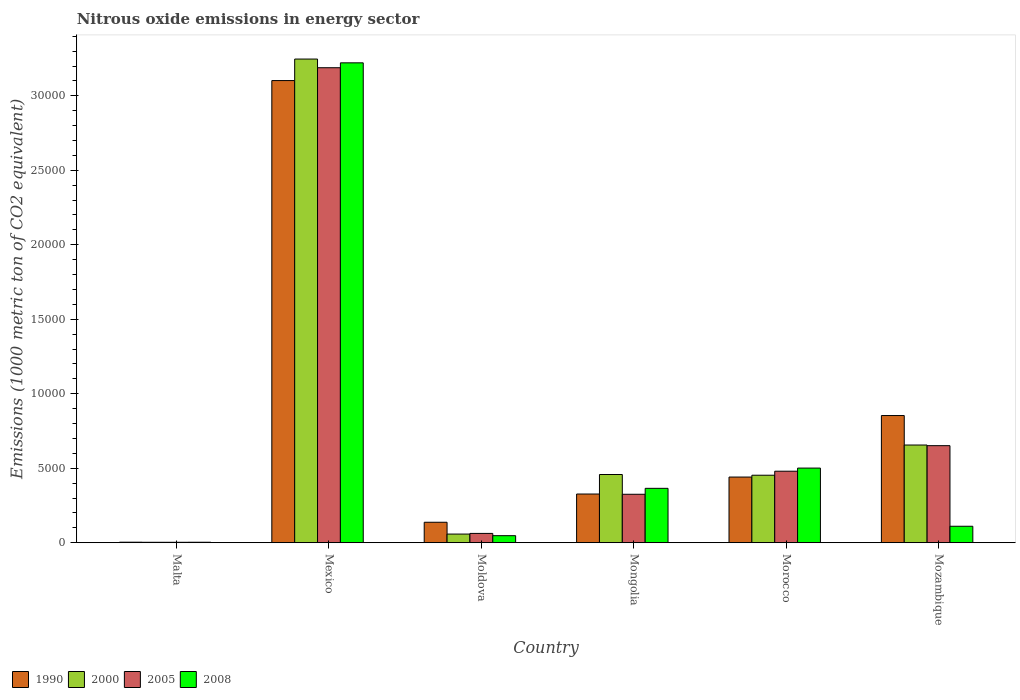How many groups of bars are there?
Ensure brevity in your answer.  6. Are the number of bars per tick equal to the number of legend labels?
Give a very brief answer. Yes. How many bars are there on the 4th tick from the left?
Offer a terse response. 4. What is the label of the 5th group of bars from the left?
Keep it short and to the point. Morocco. In how many cases, is the number of bars for a given country not equal to the number of legend labels?
Your answer should be compact. 0. What is the amount of nitrous oxide emitted in 2005 in Mozambique?
Make the answer very short. 6514.2. Across all countries, what is the maximum amount of nitrous oxide emitted in 2008?
Your response must be concise. 3.22e+04. Across all countries, what is the minimum amount of nitrous oxide emitted in 2005?
Offer a terse response. 28.7. In which country was the amount of nitrous oxide emitted in 2000 minimum?
Offer a terse response. Malta. What is the total amount of nitrous oxide emitted in 2000 in the graph?
Give a very brief answer. 4.87e+04. What is the difference between the amount of nitrous oxide emitted in 2000 in Moldova and that in Mongolia?
Keep it short and to the point. -3998.7. What is the difference between the amount of nitrous oxide emitted in 1990 in Moldova and the amount of nitrous oxide emitted in 2000 in Mongolia?
Your response must be concise. -3205.3. What is the average amount of nitrous oxide emitted in 2005 per country?
Your answer should be compact. 7850.5. What is the difference between the amount of nitrous oxide emitted of/in 2005 and amount of nitrous oxide emitted of/in 2008 in Malta?
Your answer should be very brief. -2.4. What is the ratio of the amount of nitrous oxide emitted in 2005 in Moldova to that in Morocco?
Provide a succinct answer. 0.13. What is the difference between the highest and the second highest amount of nitrous oxide emitted in 1990?
Your answer should be very brief. -4130.1. What is the difference between the highest and the lowest amount of nitrous oxide emitted in 1990?
Give a very brief answer. 3.10e+04. In how many countries, is the amount of nitrous oxide emitted in 1990 greater than the average amount of nitrous oxide emitted in 1990 taken over all countries?
Ensure brevity in your answer.  2. Is the sum of the amount of nitrous oxide emitted in 2008 in Moldova and Mongolia greater than the maximum amount of nitrous oxide emitted in 1990 across all countries?
Your response must be concise. No. What is the difference between two consecutive major ticks on the Y-axis?
Your answer should be very brief. 5000. Are the values on the major ticks of Y-axis written in scientific E-notation?
Your answer should be very brief. No. Does the graph contain any zero values?
Your answer should be very brief. No. Does the graph contain grids?
Your answer should be compact. No. Where does the legend appear in the graph?
Keep it short and to the point. Bottom left. How are the legend labels stacked?
Ensure brevity in your answer.  Horizontal. What is the title of the graph?
Provide a short and direct response. Nitrous oxide emissions in energy sector. Does "1973" appear as one of the legend labels in the graph?
Your answer should be very brief. No. What is the label or title of the Y-axis?
Offer a terse response. Emissions (1000 metric ton of CO2 equivalent). What is the Emissions (1000 metric ton of CO2 equivalent) in 2000 in Malta?
Your answer should be compact. 28.2. What is the Emissions (1000 metric ton of CO2 equivalent) in 2005 in Malta?
Your answer should be very brief. 28.7. What is the Emissions (1000 metric ton of CO2 equivalent) in 2008 in Malta?
Offer a terse response. 31.1. What is the Emissions (1000 metric ton of CO2 equivalent) of 1990 in Mexico?
Offer a very short reply. 3.10e+04. What is the Emissions (1000 metric ton of CO2 equivalent) of 2000 in Mexico?
Make the answer very short. 3.25e+04. What is the Emissions (1000 metric ton of CO2 equivalent) of 2005 in Mexico?
Offer a very short reply. 3.19e+04. What is the Emissions (1000 metric ton of CO2 equivalent) of 2008 in Mexico?
Provide a short and direct response. 3.22e+04. What is the Emissions (1000 metric ton of CO2 equivalent) in 1990 in Moldova?
Provide a short and direct response. 1373.3. What is the Emissions (1000 metric ton of CO2 equivalent) of 2000 in Moldova?
Provide a succinct answer. 579.9. What is the Emissions (1000 metric ton of CO2 equivalent) in 2005 in Moldova?
Your response must be concise. 624.1. What is the Emissions (1000 metric ton of CO2 equivalent) in 2008 in Moldova?
Keep it short and to the point. 472.4. What is the Emissions (1000 metric ton of CO2 equivalent) of 1990 in Mongolia?
Keep it short and to the point. 3267.8. What is the Emissions (1000 metric ton of CO2 equivalent) in 2000 in Mongolia?
Provide a succinct answer. 4578.6. What is the Emissions (1000 metric ton of CO2 equivalent) in 2005 in Mongolia?
Offer a very short reply. 3251.9. What is the Emissions (1000 metric ton of CO2 equivalent) of 2008 in Mongolia?
Keep it short and to the point. 3650.1. What is the Emissions (1000 metric ton of CO2 equivalent) in 1990 in Morocco?
Your response must be concise. 4406.9. What is the Emissions (1000 metric ton of CO2 equivalent) in 2000 in Morocco?
Make the answer very short. 4529.5. What is the Emissions (1000 metric ton of CO2 equivalent) of 2005 in Morocco?
Make the answer very short. 4799.4. What is the Emissions (1000 metric ton of CO2 equivalent) in 2008 in Morocco?
Your response must be concise. 5008.9. What is the Emissions (1000 metric ton of CO2 equivalent) in 1990 in Mozambique?
Ensure brevity in your answer.  8537. What is the Emissions (1000 metric ton of CO2 equivalent) in 2000 in Mozambique?
Ensure brevity in your answer.  6557.2. What is the Emissions (1000 metric ton of CO2 equivalent) of 2005 in Mozambique?
Your answer should be very brief. 6514.2. What is the Emissions (1000 metric ton of CO2 equivalent) in 2008 in Mozambique?
Make the answer very short. 1104.1. Across all countries, what is the maximum Emissions (1000 metric ton of CO2 equivalent) of 1990?
Give a very brief answer. 3.10e+04. Across all countries, what is the maximum Emissions (1000 metric ton of CO2 equivalent) in 2000?
Make the answer very short. 3.25e+04. Across all countries, what is the maximum Emissions (1000 metric ton of CO2 equivalent) in 2005?
Your response must be concise. 3.19e+04. Across all countries, what is the maximum Emissions (1000 metric ton of CO2 equivalent) in 2008?
Offer a very short reply. 3.22e+04. Across all countries, what is the minimum Emissions (1000 metric ton of CO2 equivalent) of 1990?
Your response must be concise. 35. Across all countries, what is the minimum Emissions (1000 metric ton of CO2 equivalent) of 2000?
Your response must be concise. 28.2. Across all countries, what is the minimum Emissions (1000 metric ton of CO2 equivalent) in 2005?
Make the answer very short. 28.7. Across all countries, what is the minimum Emissions (1000 metric ton of CO2 equivalent) of 2008?
Keep it short and to the point. 31.1. What is the total Emissions (1000 metric ton of CO2 equivalent) in 1990 in the graph?
Ensure brevity in your answer.  4.86e+04. What is the total Emissions (1000 metric ton of CO2 equivalent) of 2000 in the graph?
Offer a very short reply. 4.87e+04. What is the total Emissions (1000 metric ton of CO2 equivalent) in 2005 in the graph?
Provide a short and direct response. 4.71e+04. What is the total Emissions (1000 metric ton of CO2 equivalent) of 2008 in the graph?
Offer a very short reply. 4.25e+04. What is the difference between the Emissions (1000 metric ton of CO2 equivalent) in 1990 in Malta and that in Mexico?
Keep it short and to the point. -3.10e+04. What is the difference between the Emissions (1000 metric ton of CO2 equivalent) in 2000 in Malta and that in Mexico?
Make the answer very short. -3.24e+04. What is the difference between the Emissions (1000 metric ton of CO2 equivalent) in 2005 in Malta and that in Mexico?
Provide a short and direct response. -3.19e+04. What is the difference between the Emissions (1000 metric ton of CO2 equivalent) of 2008 in Malta and that in Mexico?
Ensure brevity in your answer.  -3.22e+04. What is the difference between the Emissions (1000 metric ton of CO2 equivalent) of 1990 in Malta and that in Moldova?
Your answer should be compact. -1338.3. What is the difference between the Emissions (1000 metric ton of CO2 equivalent) in 2000 in Malta and that in Moldova?
Your answer should be compact. -551.7. What is the difference between the Emissions (1000 metric ton of CO2 equivalent) in 2005 in Malta and that in Moldova?
Give a very brief answer. -595.4. What is the difference between the Emissions (1000 metric ton of CO2 equivalent) of 2008 in Malta and that in Moldova?
Your response must be concise. -441.3. What is the difference between the Emissions (1000 metric ton of CO2 equivalent) of 1990 in Malta and that in Mongolia?
Your response must be concise. -3232.8. What is the difference between the Emissions (1000 metric ton of CO2 equivalent) of 2000 in Malta and that in Mongolia?
Ensure brevity in your answer.  -4550.4. What is the difference between the Emissions (1000 metric ton of CO2 equivalent) of 2005 in Malta and that in Mongolia?
Provide a short and direct response. -3223.2. What is the difference between the Emissions (1000 metric ton of CO2 equivalent) of 2008 in Malta and that in Mongolia?
Provide a short and direct response. -3619. What is the difference between the Emissions (1000 metric ton of CO2 equivalent) in 1990 in Malta and that in Morocco?
Provide a short and direct response. -4371.9. What is the difference between the Emissions (1000 metric ton of CO2 equivalent) in 2000 in Malta and that in Morocco?
Offer a terse response. -4501.3. What is the difference between the Emissions (1000 metric ton of CO2 equivalent) in 2005 in Malta and that in Morocco?
Make the answer very short. -4770.7. What is the difference between the Emissions (1000 metric ton of CO2 equivalent) of 2008 in Malta and that in Morocco?
Your response must be concise. -4977.8. What is the difference between the Emissions (1000 metric ton of CO2 equivalent) of 1990 in Malta and that in Mozambique?
Make the answer very short. -8502. What is the difference between the Emissions (1000 metric ton of CO2 equivalent) of 2000 in Malta and that in Mozambique?
Give a very brief answer. -6529. What is the difference between the Emissions (1000 metric ton of CO2 equivalent) in 2005 in Malta and that in Mozambique?
Your answer should be very brief. -6485.5. What is the difference between the Emissions (1000 metric ton of CO2 equivalent) of 2008 in Malta and that in Mozambique?
Give a very brief answer. -1073. What is the difference between the Emissions (1000 metric ton of CO2 equivalent) of 1990 in Mexico and that in Moldova?
Make the answer very short. 2.96e+04. What is the difference between the Emissions (1000 metric ton of CO2 equivalent) of 2000 in Mexico and that in Moldova?
Your answer should be compact. 3.19e+04. What is the difference between the Emissions (1000 metric ton of CO2 equivalent) of 2005 in Mexico and that in Moldova?
Your answer should be compact. 3.13e+04. What is the difference between the Emissions (1000 metric ton of CO2 equivalent) in 2008 in Mexico and that in Moldova?
Ensure brevity in your answer.  3.17e+04. What is the difference between the Emissions (1000 metric ton of CO2 equivalent) of 1990 in Mexico and that in Mongolia?
Make the answer very short. 2.78e+04. What is the difference between the Emissions (1000 metric ton of CO2 equivalent) of 2000 in Mexico and that in Mongolia?
Your answer should be very brief. 2.79e+04. What is the difference between the Emissions (1000 metric ton of CO2 equivalent) of 2005 in Mexico and that in Mongolia?
Your answer should be very brief. 2.86e+04. What is the difference between the Emissions (1000 metric ton of CO2 equivalent) of 2008 in Mexico and that in Mongolia?
Your answer should be very brief. 2.86e+04. What is the difference between the Emissions (1000 metric ton of CO2 equivalent) of 1990 in Mexico and that in Morocco?
Provide a succinct answer. 2.66e+04. What is the difference between the Emissions (1000 metric ton of CO2 equivalent) of 2000 in Mexico and that in Morocco?
Offer a very short reply. 2.79e+04. What is the difference between the Emissions (1000 metric ton of CO2 equivalent) in 2005 in Mexico and that in Morocco?
Give a very brief answer. 2.71e+04. What is the difference between the Emissions (1000 metric ton of CO2 equivalent) of 2008 in Mexico and that in Morocco?
Offer a very short reply. 2.72e+04. What is the difference between the Emissions (1000 metric ton of CO2 equivalent) in 1990 in Mexico and that in Mozambique?
Ensure brevity in your answer.  2.25e+04. What is the difference between the Emissions (1000 metric ton of CO2 equivalent) of 2000 in Mexico and that in Mozambique?
Ensure brevity in your answer.  2.59e+04. What is the difference between the Emissions (1000 metric ton of CO2 equivalent) in 2005 in Mexico and that in Mozambique?
Make the answer very short. 2.54e+04. What is the difference between the Emissions (1000 metric ton of CO2 equivalent) in 2008 in Mexico and that in Mozambique?
Ensure brevity in your answer.  3.11e+04. What is the difference between the Emissions (1000 metric ton of CO2 equivalent) in 1990 in Moldova and that in Mongolia?
Provide a short and direct response. -1894.5. What is the difference between the Emissions (1000 metric ton of CO2 equivalent) in 2000 in Moldova and that in Mongolia?
Your answer should be compact. -3998.7. What is the difference between the Emissions (1000 metric ton of CO2 equivalent) in 2005 in Moldova and that in Mongolia?
Keep it short and to the point. -2627.8. What is the difference between the Emissions (1000 metric ton of CO2 equivalent) in 2008 in Moldova and that in Mongolia?
Your answer should be compact. -3177.7. What is the difference between the Emissions (1000 metric ton of CO2 equivalent) of 1990 in Moldova and that in Morocco?
Offer a very short reply. -3033.6. What is the difference between the Emissions (1000 metric ton of CO2 equivalent) of 2000 in Moldova and that in Morocco?
Ensure brevity in your answer.  -3949.6. What is the difference between the Emissions (1000 metric ton of CO2 equivalent) in 2005 in Moldova and that in Morocco?
Give a very brief answer. -4175.3. What is the difference between the Emissions (1000 metric ton of CO2 equivalent) in 2008 in Moldova and that in Morocco?
Your answer should be compact. -4536.5. What is the difference between the Emissions (1000 metric ton of CO2 equivalent) in 1990 in Moldova and that in Mozambique?
Give a very brief answer. -7163.7. What is the difference between the Emissions (1000 metric ton of CO2 equivalent) of 2000 in Moldova and that in Mozambique?
Ensure brevity in your answer.  -5977.3. What is the difference between the Emissions (1000 metric ton of CO2 equivalent) in 2005 in Moldova and that in Mozambique?
Your answer should be very brief. -5890.1. What is the difference between the Emissions (1000 metric ton of CO2 equivalent) in 2008 in Moldova and that in Mozambique?
Offer a very short reply. -631.7. What is the difference between the Emissions (1000 metric ton of CO2 equivalent) of 1990 in Mongolia and that in Morocco?
Your answer should be compact. -1139.1. What is the difference between the Emissions (1000 metric ton of CO2 equivalent) of 2000 in Mongolia and that in Morocco?
Give a very brief answer. 49.1. What is the difference between the Emissions (1000 metric ton of CO2 equivalent) in 2005 in Mongolia and that in Morocco?
Give a very brief answer. -1547.5. What is the difference between the Emissions (1000 metric ton of CO2 equivalent) of 2008 in Mongolia and that in Morocco?
Make the answer very short. -1358.8. What is the difference between the Emissions (1000 metric ton of CO2 equivalent) in 1990 in Mongolia and that in Mozambique?
Provide a succinct answer. -5269.2. What is the difference between the Emissions (1000 metric ton of CO2 equivalent) of 2000 in Mongolia and that in Mozambique?
Your answer should be very brief. -1978.6. What is the difference between the Emissions (1000 metric ton of CO2 equivalent) of 2005 in Mongolia and that in Mozambique?
Offer a terse response. -3262.3. What is the difference between the Emissions (1000 metric ton of CO2 equivalent) in 2008 in Mongolia and that in Mozambique?
Give a very brief answer. 2546. What is the difference between the Emissions (1000 metric ton of CO2 equivalent) in 1990 in Morocco and that in Mozambique?
Provide a short and direct response. -4130.1. What is the difference between the Emissions (1000 metric ton of CO2 equivalent) in 2000 in Morocco and that in Mozambique?
Offer a terse response. -2027.7. What is the difference between the Emissions (1000 metric ton of CO2 equivalent) in 2005 in Morocco and that in Mozambique?
Your answer should be compact. -1714.8. What is the difference between the Emissions (1000 metric ton of CO2 equivalent) of 2008 in Morocco and that in Mozambique?
Keep it short and to the point. 3904.8. What is the difference between the Emissions (1000 metric ton of CO2 equivalent) in 1990 in Malta and the Emissions (1000 metric ton of CO2 equivalent) in 2000 in Mexico?
Ensure brevity in your answer.  -3.24e+04. What is the difference between the Emissions (1000 metric ton of CO2 equivalent) of 1990 in Malta and the Emissions (1000 metric ton of CO2 equivalent) of 2005 in Mexico?
Give a very brief answer. -3.18e+04. What is the difference between the Emissions (1000 metric ton of CO2 equivalent) in 1990 in Malta and the Emissions (1000 metric ton of CO2 equivalent) in 2008 in Mexico?
Give a very brief answer. -3.22e+04. What is the difference between the Emissions (1000 metric ton of CO2 equivalent) in 2000 in Malta and the Emissions (1000 metric ton of CO2 equivalent) in 2005 in Mexico?
Your response must be concise. -3.19e+04. What is the difference between the Emissions (1000 metric ton of CO2 equivalent) in 2000 in Malta and the Emissions (1000 metric ton of CO2 equivalent) in 2008 in Mexico?
Ensure brevity in your answer.  -3.22e+04. What is the difference between the Emissions (1000 metric ton of CO2 equivalent) in 2005 in Malta and the Emissions (1000 metric ton of CO2 equivalent) in 2008 in Mexico?
Keep it short and to the point. -3.22e+04. What is the difference between the Emissions (1000 metric ton of CO2 equivalent) of 1990 in Malta and the Emissions (1000 metric ton of CO2 equivalent) of 2000 in Moldova?
Offer a very short reply. -544.9. What is the difference between the Emissions (1000 metric ton of CO2 equivalent) in 1990 in Malta and the Emissions (1000 metric ton of CO2 equivalent) in 2005 in Moldova?
Offer a terse response. -589.1. What is the difference between the Emissions (1000 metric ton of CO2 equivalent) of 1990 in Malta and the Emissions (1000 metric ton of CO2 equivalent) of 2008 in Moldova?
Offer a very short reply. -437.4. What is the difference between the Emissions (1000 metric ton of CO2 equivalent) of 2000 in Malta and the Emissions (1000 metric ton of CO2 equivalent) of 2005 in Moldova?
Make the answer very short. -595.9. What is the difference between the Emissions (1000 metric ton of CO2 equivalent) in 2000 in Malta and the Emissions (1000 metric ton of CO2 equivalent) in 2008 in Moldova?
Give a very brief answer. -444.2. What is the difference between the Emissions (1000 metric ton of CO2 equivalent) in 2005 in Malta and the Emissions (1000 metric ton of CO2 equivalent) in 2008 in Moldova?
Give a very brief answer. -443.7. What is the difference between the Emissions (1000 metric ton of CO2 equivalent) of 1990 in Malta and the Emissions (1000 metric ton of CO2 equivalent) of 2000 in Mongolia?
Provide a short and direct response. -4543.6. What is the difference between the Emissions (1000 metric ton of CO2 equivalent) in 1990 in Malta and the Emissions (1000 metric ton of CO2 equivalent) in 2005 in Mongolia?
Make the answer very short. -3216.9. What is the difference between the Emissions (1000 metric ton of CO2 equivalent) of 1990 in Malta and the Emissions (1000 metric ton of CO2 equivalent) of 2008 in Mongolia?
Provide a short and direct response. -3615.1. What is the difference between the Emissions (1000 metric ton of CO2 equivalent) in 2000 in Malta and the Emissions (1000 metric ton of CO2 equivalent) in 2005 in Mongolia?
Make the answer very short. -3223.7. What is the difference between the Emissions (1000 metric ton of CO2 equivalent) of 2000 in Malta and the Emissions (1000 metric ton of CO2 equivalent) of 2008 in Mongolia?
Provide a short and direct response. -3621.9. What is the difference between the Emissions (1000 metric ton of CO2 equivalent) of 2005 in Malta and the Emissions (1000 metric ton of CO2 equivalent) of 2008 in Mongolia?
Give a very brief answer. -3621.4. What is the difference between the Emissions (1000 metric ton of CO2 equivalent) in 1990 in Malta and the Emissions (1000 metric ton of CO2 equivalent) in 2000 in Morocco?
Make the answer very short. -4494.5. What is the difference between the Emissions (1000 metric ton of CO2 equivalent) of 1990 in Malta and the Emissions (1000 metric ton of CO2 equivalent) of 2005 in Morocco?
Your response must be concise. -4764.4. What is the difference between the Emissions (1000 metric ton of CO2 equivalent) in 1990 in Malta and the Emissions (1000 metric ton of CO2 equivalent) in 2008 in Morocco?
Ensure brevity in your answer.  -4973.9. What is the difference between the Emissions (1000 metric ton of CO2 equivalent) of 2000 in Malta and the Emissions (1000 metric ton of CO2 equivalent) of 2005 in Morocco?
Your answer should be very brief. -4771.2. What is the difference between the Emissions (1000 metric ton of CO2 equivalent) of 2000 in Malta and the Emissions (1000 metric ton of CO2 equivalent) of 2008 in Morocco?
Keep it short and to the point. -4980.7. What is the difference between the Emissions (1000 metric ton of CO2 equivalent) in 2005 in Malta and the Emissions (1000 metric ton of CO2 equivalent) in 2008 in Morocco?
Offer a very short reply. -4980.2. What is the difference between the Emissions (1000 metric ton of CO2 equivalent) of 1990 in Malta and the Emissions (1000 metric ton of CO2 equivalent) of 2000 in Mozambique?
Provide a short and direct response. -6522.2. What is the difference between the Emissions (1000 metric ton of CO2 equivalent) of 1990 in Malta and the Emissions (1000 metric ton of CO2 equivalent) of 2005 in Mozambique?
Ensure brevity in your answer.  -6479.2. What is the difference between the Emissions (1000 metric ton of CO2 equivalent) of 1990 in Malta and the Emissions (1000 metric ton of CO2 equivalent) of 2008 in Mozambique?
Your answer should be compact. -1069.1. What is the difference between the Emissions (1000 metric ton of CO2 equivalent) in 2000 in Malta and the Emissions (1000 metric ton of CO2 equivalent) in 2005 in Mozambique?
Ensure brevity in your answer.  -6486. What is the difference between the Emissions (1000 metric ton of CO2 equivalent) in 2000 in Malta and the Emissions (1000 metric ton of CO2 equivalent) in 2008 in Mozambique?
Your answer should be compact. -1075.9. What is the difference between the Emissions (1000 metric ton of CO2 equivalent) of 2005 in Malta and the Emissions (1000 metric ton of CO2 equivalent) of 2008 in Mozambique?
Make the answer very short. -1075.4. What is the difference between the Emissions (1000 metric ton of CO2 equivalent) of 1990 in Mexico and the Emissions (1000 metric ton of CO2 equivalent) of 2000 in Moldova?
Your answer should be compact. 3.04e+04. What is the difference between the Emissions (1000 metric ton of CO2 equivalent) of 1990 in Mexico and the Emissions (1000 metric ton of CO2 equivalent) of 2005 in Moldova?
Offer a very short reply. 3.04e+04. What is the difference between the Emissions (1000 metric ton of CO2 equivalent) of 1990 in Mexico and the Emissions (1000 metric ton of CO2 equivalent) of 2008 in Moldova?
Your response must be concise. 3.06e+04. What is the difference between the Emissions (1000 metric ton of CO2 equivalent) of 2000 in Mexico and the Emissions (1000 metric ton of CO2 equivalent) of 2005 in Moldova?
Ensure brevity in your answer.  3.18e+04. What is the difference between the Emissions (1000 metric ton of CO2 equivalent) of 2000 in Mexico and the Emissions (1000 metric ton of CO2 equivalent) of 2008 in Moldova?
Provide a short and direct response. 3.20e+04. What is the difference between the Emissions (1000 metric ton of CO2 equivalent) of 2005 in Mexico and the Emissions (1000 metric ton of CO2 equivalent) of 2008 in Moldova?
Your answer should be compact. 3.14e+04. What is the difference between the Emissions (1000 metric ton of CO2 equivalent) of 1990 in Mexico and the Emissions (1000 metric ton of CO2 equivalent) of 2000 in Mongolia?
Your answer should be very brief. 2.64e+04. What is the difference between the Emissions (1000 metric ton of CO2 equivalent) in 1990 in Mexico and the Emissions (1000 metric ton of CO2 equivalent) in 2005 in Mongolia?
Make the answer very short. 2.78e+04. What is the difference between the Emissions (1000 metric ton of CO2 equivalent) in 1990 in Mexico and the Emissions (1000 metric ton of CO2 equivalent) in 2008 in Mongolia?
Your answer should be very brief. 2.74e+04. What is the difference between the Emissions (1000 metric ton of CO2 equivalent) of 2000 in Mexico and the Emissions (1000 metric ton of CO2 equivalent) of 2005 in Mongolia?
Keep it short and to the point. 2.92e+04. What is the difference between the Emissions (1000 metric ton of CO2 equivalent) of 2000 in Mexico and the Emissions (1000 metric ton of CO2 equivalent) of 2008 in Mongolia?
Keep it short and to the point. 2.88e+04. What is the difference between the Emissions (1000 metric ton of CO2 equivalent) of 2005 in Mexico and the Emissions (1000 metric ton of CO2 equivalent) of 2008 in Mongolia?
Your answer should be compact. 2.82e+04. What is the difference between the Emissions (1000 metric ton of CO2 equivalent) of 1990 in Mexico and the Emissions (1000 metric ton of CO2 equivalent) of 2000 in Morocco?
Give a very brief answer. 2.65e+04. What is the difference between the Emissions (1000 metric ton of CO2 equivalent) in 1990 in Mexico and the Emissions (1000 metric ton of CO2 equivalent) in 2005 in Morocco?
Offer a very short reply. 2.62e+04. What is the difference between the Emissions (1000 metric ton of CO2 equivalent) of 1990 in Mexico and the Emissions (1000 metric ton of CO2 equivalent) of 2008 in Morocco?
Your response must be concise. 2.60e+04. What is the difference between the Emissions (1000 metric ton of CO2 equivalent) in 2000 in Mexico and the Emissions (1000 metric ton of CO2 equivalent) in 2005 in Morocco?
Make the answer very short. 2.77e+04. What is the difference between the Emissions (1000 metric ton of CO2 equivalent) of 2000 in Mexico and the Emissions (1000 metric ton of CO2 equivalent) of 2008 in Morocco?
Make the answer very short. 2.75e+04. What is the difference between the Emissions (1000 metric ton of CO2 equivalent) in 2005 in Mexico and the Emissions (1000 metric ton of CO2 equivalent) in 2008 in Morocco?
Give a very brief answer. 2.69e+04. What is the difference between the Emissions (1000 metric ton of CO2 equivalent) in 1990 in Mexico and the Emissions (1000 metric ton of CO2 equivalent) in 2000 in Mozambique?
Give a very brief answer. 2.45e+04. What is the difference between the Emissions (1000 metric ton of CO2 equivalent) in 1990 in Mexico and the Emissions (1000 metric ton of CO2 equivalent) in 2005 in Mozambique?
Keep it short and to the point. 2.45e+04. What is the difference between the Emissions (1000 metric ton of CO2 equivalent) in 1990 in Mexico and the Emissions (1000 metric ton of CO2 equivalent) in 2008 in Mozambique?
Keep it short and to the point. 2.99e+04. What is the difference between the Emissions (1000 metric ton of CO2 equivalent) in 2000 in Mexico and the Emissions (1000 metric ton of CO2 equivalent) in 2005 in Mozambique?
Keep it short and to the point. 2.60e+04. What is the difference between the Emissions (1000 metric ton of CO2 equivalent) in 2000 in Mexico and the Emissions (1000 metric ton of CO2 equivalent) in 2008 in Mozambique?
Give a very brief answer. 3.14e+04. What is the difference between the Emissions (1000 metric ton of CO2 equivalent) of 2005 in Mexico and the Emissions (1000 metric ton of CO2 equivalent) of 2008 in Mozambique?
Give a very brief answer. 3.08e+04. What is the difference between the Emissions (1000 metric ton of CO2 equivalent) in 1990 in Moldova and the Emissions (1000 metric ton of CO2 equivalent) in 2000 in Mongolia?
Keep it short and to the point. -3205.3. What is the difference between the Emissions (1000 metric ton of CO2 equivalent) of 1990 in Moldova and the Emissions (1000 metric ton of CO2 equivalent) of 2005 in Mongolia?
Give a very brief answer. -1878.6. What is the difference between the Emissions (1000 metric ton of CO2 equivalent) of 1990 in Moldova and the Emissions (1000 metric ton of CO2 equivalent) of 2008 in Mongolia?
Make the answer very short. -2276.8. What is the difference between the Emissions (1000 metric ton of CO2 equivalent) of 2000 in Moldova and the Emissions (1000 metric ton of CO2 equivalent) of 2005 in Mongolia?
Your answer should be compact. -2672. What is the difference between the Emissions (1000 metric ton of CO2 equivalent) of 2000 in Moldova and the Emissions (1000 metric ton of CO2 equivalent) of 2008 in Mongolia?
Offer a terse response. -3070.2. What is the difference between the Emissions (1000 metric ton of CO2 equivalent) of 2005 in Moldova and the Emissions (1000 metric ton of CO2 equivalent) of 2008 in Mongolia?
Your answer should be very brief. -3026. What is the difference between the Emissions (1000 metric ton of CO2 equivalent) in 1990 in Moldova and the Emissions (1000 metric ton of CO2 equivalent) in 2000 in Morocco?
Your answer should be compact. -3156.2. What is the difference between the Emissions (1000 metric ton of CO2 equivalent) in 1990 in Moldova and the Emissions (1000 metric ton of CO2 equivalent) in 2005 in Morocco?
Offer a terse response. -3426.1. What is the difference between the Emissions (1000 metric ton of CO2 equivalent) of 1990 in Moldova and the Emissions (1000 metric ton of CO2 equivalent) of 2008 in Morocco?
Your response must be concise. -3635.6. What is the difference between the Emissions (1000 metric ton of CO2 equivalent) in 2000 in Moldova and the Emissions (1000 metric ton of CO2 equivalent) in 2005 in Morocco?
Your response must be concise. -4219.5. What is the difference between the Emissions (1000 metric ton of CO2 equivalent) of 2000 in Moldova and the Emissions (1000 metric ton of CO2 equivalent) of 2008 in Morocco?
Make the answer very short. -4429. What is the difference between the Emissions (1000 metric ton of CO2 equivalent) of 2005 in Moldova and the Emissions (1000 metric ton of CO2 equivalent) of 2008 in Morocco?
Ensure brevity in your answer.  -4384.8. What is the difference between the Emissions (1000 metric ton of CO2 equivalent) in 1990 in Moldova and the Emissions (1000 metric ton of CO2 equivalent) in 2000 in Mozambique?
Offer a terse response. -5183.9. What is the difference between the Emissions (1000 metric ton of CO2 equivalent) in 1990 in Moldova and the Emissions (1000 metric ton of CO2 equivalent) in 2005 in Mozambique?
Ensure brevity in your answer.  -5140.9. What is the difference between the Emissions (1000 metric ton of CO2 equivalent) of 1990 in Moldova and the Emissions (1000 metric ton of CO2 equivalent) of 2008 in Mozambique?
Provide a short and direct response. 269.2. What is the difference between the Emissions (1000 metric ton of CO2 equivalent) in 2000 in Moldova and the Emissions (1000 metric ton of CO2 equivalent) in 2005 in Mozambique?
Your answer should be very brief. -5934.3. What is the difference between the Emissions (1000 metric ton of CO2 equivalent) in 2000 in Moldova and the Emissions (1000 metric ton of CO2 equivalent) in 2008 in Mozambique?
Offer a terse response. -524.2. What is the difference between the Emissions (1000 metric ton of CO2 equivalent) in 2005 in Moldova and the Emissions (1000 metric ton of CO2 equivalent) in 2008 in Mozambique?
Provide a short and direct response. -480. What is the difference between the Emissions (1000 metric ton of CO2 equivalent) of 1990 in Mongolia and the Emissions (1000 metric ton of CO2 equivalent) of 2000 in Morocco?
Give a very brief answer. -1261.7. What is the difference between the Emissions (1000 metric ton of CO2 equivalent) in 1990 in Mongolia and the Emissions (1000 metric ton of CO2 equivalent) in 2005 in Morocco?
Make the answer very short. -1531.6. What is the difference between the Emissions (1000 metric ton of CO2 equivalent) of 1990 in Mongolia and the Emissions (1000 metric ton of CO2 equivalent) of 2008 in Morocco?
Give a very brief answer. -1741.1. What is the difference between the Emissions (1000 metric ton of CO2 equivalent) in 2000 in Mongolia and the Emissions (1000 metric ton of CO2 equivalent) in 2005 in Morocco?
Your response must be concise. -220.8. What is the difference between the Emissions (1000 metric ton of CO2 equivalent) of 2000 in Mongolia and the Emissions (1000 metric ton of CO2 equivalent) of 2008 in Morocco?
Make the answer very short. -430.3. What is the difference between the Emissions (1000 metric ton of CO2 equivalent) in 2005 in Mongolia and the Emissions (1000 metric ton of CO2 equivalent) in 2008 in Morocco?
Your response must be concise. -1757. What is the difference between the Emissions (1000 metric ton of CO2 equivalent) in 1990 in Mongolia and the Emissions (1000 metric ton of CO2 equivalent) in 2000 in Mozambique?
Provide a short and direct response. -3289.4. What is the difference between the Emissions (1000 metric ton of CO2 equivalent) in 1990 in Mongolia and the Emissions (1000 metric ton of CO2 equivalent) in 2005 in Mozambique?
Provide a succinct answer. -3246.4. What is the difference between the Emissions (1000 metric ton of CO2 equivalent) in 1990 in Mongolia and the Emissions (1000 metric ton of CO2 equivalent) in 2008 in Mozambique?
Give a very brief answer. 2163.7. What is the difference between the Emissions (1000 metric ton of CO2 equivalent) of 2000 in Mongolia and the Emissions (1000 metric ton of CO2 equivalent) of 2005 in Mozambique?
Offer a terse response. -1935.6. What is the difference between the Emissions (1000 metric ton of CO2 equivalent) in 2000 in Mongolia and the Emissions (1000 metric ton of CO2 equivalent) in 2008 in Mozambique?
Make the answer very short. 3474.5. What is the difference between the Emissions (1000 metric ton of CO2 equivalent) of 2005 in Mongolia and the Emissions (1000 metric ton of CO2 equivalent) of 2008 in Mozambique?
Your answer should be very brief. 2147.8. What is the difference between the Emissions (1000 metric ton of CO2 equivalent) of 1990 in Morocco and the Emissions (1000 metric ton of CO2 equivalent) of 2000 in Mozambique?
Your answer should be very brief. -2150.3. What is the difference between the Emissions (1000 metric ton of CO2 equivalent) in 1990 in Morocco and the Emissions (1000 metric ton of CO2 equivalent) in 2005 in Mozambique?
Your answer should be compact. -2107.3. What is the difference between the Emissions (1000 metric ton of CO2 equivalent) of 1990 in Morocco and the Emissions (1000 metric ton of CO2 equivalent) of 2008 in Mozambique?
Ensure brevity in your answer.  3302.8. What is the difference between the Emissions (1000 metric ton of CO2 equivalent) in 2000 in Morocco and the Emissions (1000 metric ton of CO2 equivalent) in 2005 in Mozambique?
Offer a very short reply. -1984.7. What is the difference between the Emissions (1000 metric ton of CO2 equivalent) of 2000 in Morocco and the Emissions (1000 metric ton of CO2 equivalent) of 2008 in Mozambique?
Give a very brief answer. 3425.4. What is the difference between the Emissions (1000 metric ton of CO2 equivalent) of 2005 in Morocco and the Emissions (1000 metric ton of CO2 equivalent) of 2008 in Mozambique?
Your response must be concise. 3695.3. What is the average Emissions (1000 metric ton of CO2 equivalent) in 1990 per country?
Offer a terse response. 8107.07. What is the average Emissions (1000 metric ton of CO2 equivalent) in 2000 per country?
Provide a short and direct response. 8123.3. What is the average Emissions (1000 metric ton of CO2 equivalent) of 2005 per country?
Offer a very short reply. 7850.5. What is the average Emissions (1000 metric ton of CO2 equivalent) in 2008 per country?
Your answer should be very brief. 7079.92. What is the difference between the Emissions (1000 metric ton of CO2 equivalent) in 1990 and Emissions (1000 metric ton of CO2 equivalent) in 2000 in Malta?
Ensure brevity in your answer.  6.8. What is the difference between the Emissions (1000 metric ton of CO2 equivalent) of 1990 and Emissions (1000 metric ton of CO2 equivalent) of 2005 in Malta?
Your response must be concise. 6.3. What is the difference between the Emissions (1000 metric ton of CO2 equivalent) of 1990 and Emissions (1000 metric ton of CO2 equivalent) of 2008 in Malta?
Your response must be concise. 3.9. What is the difference between the Emissions (1000 metric ton of CO2 equivalent) of 2000 and Emissions (1000 metric ton of CO2 equivalent) of 2008 in Malta?
Provide a short and direct response. -2.9. What is the difference between the Emissions (1000 metric ton of CO2 equivalent) of 2005 and Emissions (1000 metric ton of CO2 equivalent) of 2008 in Malta?
Offer a terse response. -2.4. What is the difference between the Emissions (1000 metric ton of CO2 equivalent) of 1990 and Emissions (1000 metric ton of CO2 equivalent) of 2000 in Mexico?
Give a very brief answer. -1444. What is the difference between the Emissions (1000 metric ton of CO2 equivalent) in 1990 and Emissions (1000 metric ton of CO2 equivalent) in 2005 in Mexico?
Provide a short and direct response. -862.3. What is the difference between the Emissions (1000 metric ton of CO2 equivalent) in 1990 and Emissions (1000 metric ton of CO2 equivalent) in 2008 in Mexico?
Keep it short and to the point. -1190.5. What is the difference between the Emissions (1000 metric ton of CO2 equivalent) of 2000 and Emissions (1000 metric ton of CO2 equivalent) of 2005 in Mexico?
Provide a short and direct response. 581.7. What is the difference between the Emissions (1000 metric ton of CO2 equivalent) of 2000 and Emissions (1000 metric ton of CO2 equivalent) of 2008 in Mexico?
Offer a terse response. 253.5. What is the difference between the Emissions (1000 metric ton of CO2 equivalent) of 2005 and Emissions (1000 metric ton of CO2 equivalent) of 2008 in Mexico?
Offer a terse response. -328.2. What is the difference between the Emissions (1000 metric ton of CO2 equivalent) in 1990 and Emissions (1000 metric ton of CO2 equivalent) in 2000 in Moldova?
Offer a terse response. 793.4. What is the difference between the Emissions (1000 metric ton of CO2 equivalent) in 1990 and Emissions (1000 metric ton of CO2 equivalent) in 2005 in Moldova?
Give a very brief answer. 749.2. What is the difference between the Emissions (1000 metric ton of CO2 equivalent) of 1990 and Emissions (1000 metric ton of CO2 equivalent) of 2008 in Moldova?
Your answer should be very brief. 900.9. What is the difference between the Emissions (1000 metric ton of CO2 equivalent) of 2000 and Emissions (1000 metric ton of CO2 equivalent) of 2005 in Moldova?
Give a very brief answer. -44.2. What is the difference between the Emissions (1000 metric ton of CO2 equivalent) in 2000 and Emissions (1000 metric ton of CO2 equivalent) in 2008 in Moldova?
Ensure brevity in your answer.  107.5. What is the difference between the Emissions (1000 metric ton of CO2 equivalent) in 2005 and Emissions (1000 metric ton of CO2 equivalent) in 2008 in Moldova?
Keep it short and to the point. 151.7. What is the difference between the Emissions (1000 metric ton of CO2 equivalent) in 1990 and Emissions (1000 metric ton of CO2 equivalent) in 2000 in Mongolia?
Offer a very short reply. -1310.8. What is the difference between the Emissions (1000 metric ton of CO2 equivalent) of 1990 and Emissions (1000 metric ton of CO2 equivalent) of 2005 in Mongolia?
Offer a very short reply. 15.9. What is the difference between the Emissions (1000 metric ton of CO2 equivalent) of 1990 and Emissions (1000 metric ton of CO2 equivalent) of 2008 in Mongolia?
Ensure brevity in your answer.  -382.3. What is the difference between the Emissions (1000 metric ton of CO2 equivalent) in 2000 and Emissions (1000 metric ton of CO2 equivalent) in 2005 in Mongolia?
Keep it short and to the point. 1326.7. What is the difference between the Emissions (1000 metric ton of CO2 equivalent) of 2000 and Emissions (1000 metric ton of CO2 equivalent) of 2008 in Mongolia?
Offer a very short reply. 928.5. What is the difference between the Emissions (1000 metric ton of CO2 equivalent) of 2005 and Emissions (1000 metric ton of CO2 equivalent) of 2008 in Mongolia?
Offer a terse response. -398.2. What is the difference between the Emissions (1000 metric ton of CO2 equivalent) of 1990 and Emissions (1000 metric ton of CO2 equivalent) of 2000 in Morocco?
Make the answer very short. -122.6. What is the difference between the Emissions (1000 metric ton of CO2 equivalent) in 1990 and Emissions (1000 metric ton of CO2 equivalent) in 2005 in Morocco?
Give a very brief answer. -392.5. What is the difference between the Emissions (1000 metric ton of CO2 equivalent) of 1990 and Emissions (1000 metric ton of CO2 equivalent) of 2008 in Morocco?
Your answer should be very brief. -602. What is the difference between the Emissions (1000 metric ton of CO2 equivalent) of 2000 and Emissions (1000 metric ton of CO2 equivalent) of 2005 in Morocco?
Your answer should be compact. -269.9. What is the difference between the Emissions (1000 metric ton of CO2 equivalent) in 2000 and Emissions (1000 metric ton of CO2 equivalent) in 2008 in Morocco?
Your answer should be compact. -479.4. What is the difference between the Emissions (1000 metric ton of CO2 equivalent) in 2005 and Emissions (1000 metric ton of CO2 equivalent) in 2008 in Morocco?
Make the answer very short. -209.5. What is the difference between the Emissions (1000 metric ton of CO2 equivalent) of 1990 and Emissions (1000 metric ton of CO2 equivalent) of 2000 in Mozambique?
Offer a very short reply. 1979.8. What is the difference between the Emissions (1000 metric ton of CO2 equivalent) of 1990 and Emissions (1000 metric ton of CO2 equivalent) of 2005 in Mozambique?
Offer a terse response. 2022.8. What is the difference between the Emissions (1000 metric ton of CO2 equivalent) of 1990 and Emissions (1000 metric ton of CO2 equivalent) of 2008 in Mozambique?
Your answer should be very brief. 7432.9. What is the difference between the Emissions (1000 metric ton of CO2 equivalent) of 2000 and Emissions (1000 metric ton of CO2 equivalent) of 2005 in Mozambique?
Give a very brief answer. 43. What is the difference between the Emissions (1000 metric ton of CO2 equivalent) of 2000 and Emissions (1000 metric ton of CO2 equivalent) of 2008 in Mozambique?
Your answer should be very brief. 5453.1. What is the difference between the Emissions (1000 metric ton of CO2 equivalent) of 2005 and Emissions (1000 metric ton of CO2 equivalent) of 2008 in Mozambique?
Provide a succinct answer. 5410.1. What is the ratio of the Emissions (1000 metric ton of CO2 equivalent) of 1990 in Malta to that in Mexico?
Ensure brevity in your answer.  0. What is the ratio of the Emissions (1000 metric ton of CO2 equivalent) of 2000 in Malta to that in Mexico?
Your response must be concise. 0. What is the ratio of the Emissions (1000 metric ton of CO2 equivalent) in 2005 in Malta to that in Mexico?
Offer a very short reply. 0. What is the ratio of the Emissions (1000 metric ton of CO2 equivalent) in 2008 in Malta to that in Mexico?
Provide a succinct answer. 0. What is the ratio of the Emissions (1000 metric ton of CO2 equivalent) of 1990 in Malta to that in Moldova?
Provide a short and direct response. 0.03. What is the ratio of the Emissions (1000 metric ton of CO2 equivalent) of 2000 in Malta to that in Moldova?
Offer a terse response. 0.05. What is the ratio of the Emissions (1000 metric ton of CO2 equivalent) of 2005 in Malta to that in Moldova?
Give a very brief answer. 0.05. What is the ratio of the Emissions (1000 metric ton of CO2 equivalent) of 2008 in Malta to that in Moldova?
Offer a very short reply. 0.07. What is the ratio of the Emissions (1000 metric ton of CO2 equivalent) in 1990 in Malta to that in Mongolia?
Provide a succinct answer. 0.01. What is the ratio of the Emissions (1000 metric ton of CO2 equivalent) in 2000 in Malta to that in Mongolia?
Make the answer very short. 0.01. What is the ratio of the Emissions (1000 metric ton of CO2 equivalent) in 2005 in Malta to that in Mongolia?
Ensure brevity in your answer.  0.01. What is the ratio of the Emissions (1000 metric ton of CO2 equivalent) of 2008 in Malta to that in Mongolia?
Offer a terse response. 0.01. What is the ratio of the Emissions (1000 metric ton of CO2 equivalent) in 1990 in Malta to that in Morocco?
Provide a succinct answer. 0.01. What is the ratio of the Emissions (1000 metric ton of CO2 equivalent) in 2000 in Malta to that in Morocco?
Provide a succinct answer. 0.01. What is the ratio of the Emissions (1000 metric ton of CO2 equivalent) in 2005 in Malta to that in Morocco?
Ensure brevity in your answer.  0.01. What is the ratio of the Emissions (1000 metric ton of CO2 equivalent) of 2008 in Malta to that in Morocco?
Your response must be concise. 0.01. What is the ratio of the Emissions (1000 metric ton of CO2 equivalent) in 1990 in Malta to that in Mozambique?
Keep it short and to the point. 0. What is the ratio of the Emissions (1000 metric ton of CO2 equivalent) of 2000 in Malta to that in Mozambique?
Ensure brevity in your answer.  0. What is the ratio of the Emissions (1000 metric ton of CO2 equivalent) of 2005 in Malta to that in Mozambique?
Provide a short and direct response. 0. What is the ratio of the Emissions (1000 metric ton of CO2 equivalent) of 2008 in Malta to that in Mozambique?
Provide a succinct answer. 0.03. What is the ratio of the Emissions (1000 metric ton of CO2 equivalent) of 1990 in Mexico to that in Moldova?
Provide a short and direct response. 22.59. What is the ratio of the Emissions (1000 metric ton of CO2 equivalent) in 2000 in Mexico to that in Moldova?
Your answer should be very brief. 55.99. What is the ratio of the Emissions (1000 metric ton of CO2 equivalent) of 2005 in Mexico to that in Moldova?
Give a very brief answer. 51.09. What is the ratio of the Emissions (1000 metric ton of CO2 equivalent) in 2008 in Mexico to that in Moldova?
Your answer should be compact. 68.19. What is the ratio of the Emissions (1000 metric ton of CO2 equivalent) in 1990 in Mexico to that in Mongolia?
Your answer should be compact. 9.49. What is the ratio of the Emissions (1000 metric ton of CO2 equivalent) in 2000 in Mexico to that in Mongolia?
Provide a short and direct response. 7.09. What is the ratio of the Emissions (1000 metric ton of CO2 equivalent) of 2005 in Mexico to that in Mongolia?
Your answer should be very brief. 9.8. What is the ratio of the Emissions (1000 metric ton of CO2 equivalent) of 2008 in Mexico to that in Mongolia?
Ensure brevity in your answer.  8.83. What is the ratio of the Emissions (1000 metric ton of CO2 equivalent) in 1990 in Mexico to that in Morocco?
Make the answer very short. 7.04. What is the ratio of the Emissions (1000 metric ton of CO2 equivalent) in 2000 in Mexico to that in Morocco?
Provide a succinct answer. 7.17. What is the ratio of the Emissions (1000 metric ton of CO2 equivalent) of 2005 in Mexico to that in Morocco?
Provide a succinct answer. 6.64. What is the ratio of the Emissions (1000 metric ton of CO2 equivalent) in 2008 in Mexico to that in Morocco?
Offer a terse response. 6.43. What is the ratio of the Emissions (1000 metric ton of CO2 equivalent) in 1990 in Mexico to that in Mozambique?
Make the answer very short. 3.63. What is the ratio of the Emissions (1000 metric ton of CO2 equivalent) in 2000 in Mexico to that in Mozambique?
Your answer should be very brief. 4.95. What is the ratio of the Emissions (1000 metric ton of CO2 equivalent) in 2005 in Mexico to that in Mozambique?
Provide a short and direct response. 4.89. What is the ratio of the Emissions (1000 metric ton of CO2 equivalent) of 2008 in Mexico to that in Mozambique?
Offer a terse response. 29.18. What is the ratio of the Emissions (1000 metric ton of CO2 equivalent) in 1990 in Moldova to that in Mongolia?
Provide a short and direct response. 0.42. What is the ratio of the Emissions (1000 metric ton of CO2 equivalent) of 2000 in Moldova to that in Mongolia?
Offer a very short reply. 0.13. What is the ratio of the Emissions (1000 metric ton of CO2 equivalent) of 2005 in Moldova to that in Mongolia?
Offer a terse response. 0.19. What is the ratio of the Emissions (1000 metric ton of CO2 equivalent) of 2008 in Moldova to that in Mongolia?
Keep it short and to the point. 0.13. What is the ratio of the Emissions (1000 metric ton of CO2 equivalent) in 1990 in Moldova to that in Morocco?
Make the answer very short. 0.31. What is the ratio of the Emissions (1000 metric ton of CO2 equivalent) in 2000 in Moldova to that in Morocco?
Your response must be concise. 0.13. What is the ratio of the Emissions (1000 metric ton of CO2 equivalent) in 2005 in Moldova to that in Morocco?
Make the answer very short. 0.13. What is the ratio of the Emissions (1000 metric ton of CO2 equivalent) in 2008 in Moldova to that in Morocco?
Make the answer very short. 0.09. What is the ratio of the Emissions (1000 metric ton of CO2 equivalent) in 1990 in Moldova to that in Mozambique?
Your response must be concise. 0.16. What is the ratio of the Emissions (1000 metric ton of CO2 equivalent) in 2000 in Moldova to that in Mozambique?
Give a very brief answer. 0.09. What is the ratio of the Emissions (1000 metric ton of CO2 equivalent) of 2005 in Moldova to that in Mozambique?
Give a very brief answer. 0.1. What is the ratio of the Emissions (1000 metric ton of CO2 equivalent) in 2008 in Moldova to that in Mozambique?
Give a very brief answer. 0.43. What is the ratio of the Emissions (1000 metric ton of CO2 equivalent) in 1990 in Mongolia to that in Morocco?
Provide a succinct answer. 0.74. What is the ratio of the Emissions (1000 metric ton of CO2 equivalent) of 2000 in Mongolia to that in Morocco?
Your response must be concise. 1.01. What is the ratio of the Emissions (1000 metric ton of CO2 equivalent) of 2005 in Mongolia to that in Morocco?
Keep it short and to the point. 0.68. What is the ratio of the Emissions (1000 metric ton of CO2 equivalent) of 2008 in Mongolia to that in Morocco?
Ensure brevity in your answer.  0.73. What is the ratio of the Emissions (1000 metric ton of CO2 equivalent) of 1990 in Mongolia to that in Mozambique?
Provide a succinct answer. 0.38. What is the ratio of the Emissions (1000 metric ton of CO2 equivalent) of 2000 in Mongolia to that in Mozambique?
Provide a short and direct response. 0.7. What is the ratio of the Emissions (1000 metric ton of CO2 equivalent) of 2005 in Mongolia to that in Mozambique?
Make the answer very short. 0.5. What is the ratio of the Emissions (1000 metric ton of CO2 equivalent) of 2008 in Mongolia to that in Mozambique?
Offer a terse response. 3.31. What is the ratio of the Emissions (1000 metric ton of CO2 equivalent) in 1990 in Morocco to that in Mozambique?
Your answer should be very brief. 0.52. What is the ratio of the Emissions (1000 metric ton of CO2 equivalent) in 2000 in Morocco to that in Mozambique?
Give a very brief answer. 0.69. What is the ratio of the Emissions (1000 metric ton of CO2 equivalent) in 2005 in Morocco to that in Mozambique?
Offer a very short reply. 0.74. What is the ratio of the Emissions (1000 metric ton of CO2 equivalent) of 2008 in Morocco to that in Mozambique?
Your response must be concise. 4.54. What is the difference between the highest and the second highest Emissions (1000 metric ton of CO2 equivalent) in 1990?
Offer a terse response. 2.25e+04. What is the difference between the highest and the second highest Emissions (1000 metric ton of CO2 equivalent) in 2000?
Give a very brief answer. 2.59e+04. What is the difference between the highest and the second highest Emissions (1000 metric ton of CO2 equivalent) in 2005?
Provide a short and direct response. 2.54e+04. What is the difference between the highest and the second highest Emissions (1000 metric ton of CO2 equivalent) of 2008?
Offer a terse response. 2.72e+04. What is the difference between the highest and the lowest Emissions (1000 metric ton of CO2 equivalent) of 1990?
Make the answer very short. 3.10e+04. What is the difference between the highest and the lowest Emissions (1000 metric ton of CO2 equivalent) of 2000?
Keep it short and to the point. 3.24e+04. What is the difference between the highest and the lowest Emissions (1000 metric ton of CO2 equivalent) in 2005?
Your answer should be compact. 3.19e+04. What is the difference between the highest and the lowest Emissions (1000 metric ton of CO2 equivalent) in 2008?
Your answer should be very brief. 3.22e+04. 